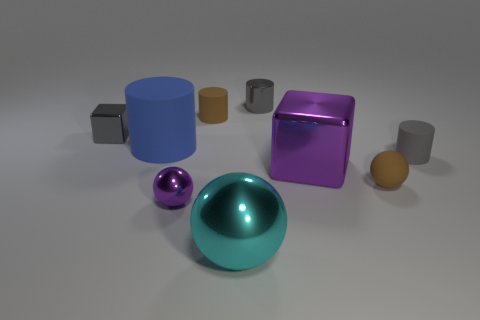Subtract all tiny shiny cylinders. How many cylinders are left? 3 Subtract all cyan spheres. How many spheres are left? 2 Add 1 small blue spheres. How many objects exist? 10 Subtract all blocks. How many objects are left? 7 Subtract 3 balls. How many balls are left? 0 Add 6 large blocks. How many large blocks exist? 7 Subtract 0 red spheres. How many objects are left? 9 Subtract all brown cubes. Subtract all blue cylinders. How many cubes are left? 2 Subtract all yellow blocks. How many cyan spheres are left? 1 Subtract all tiny gray metal cylinders. Subtract all big cyan shiny objects. How many objects are left? 7 